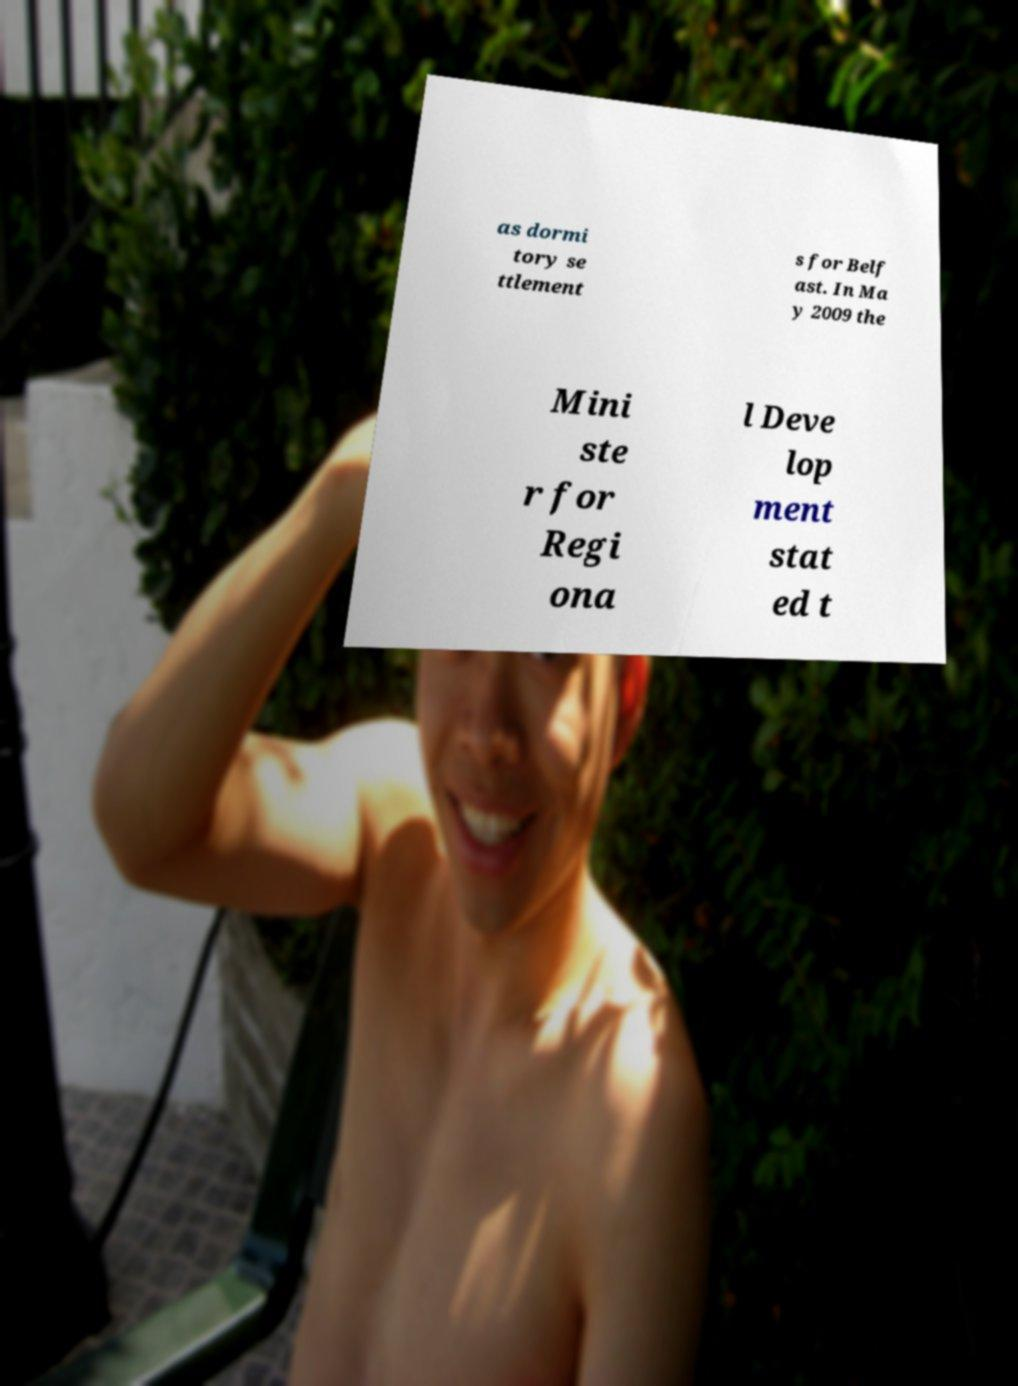Please read and relay the text visible in this image. What does it say? as dormi tory se ttlement s for Belf ast. In Ma y 2009 the Mini ste r for Regi ona l Deve lop ment stat ed t 